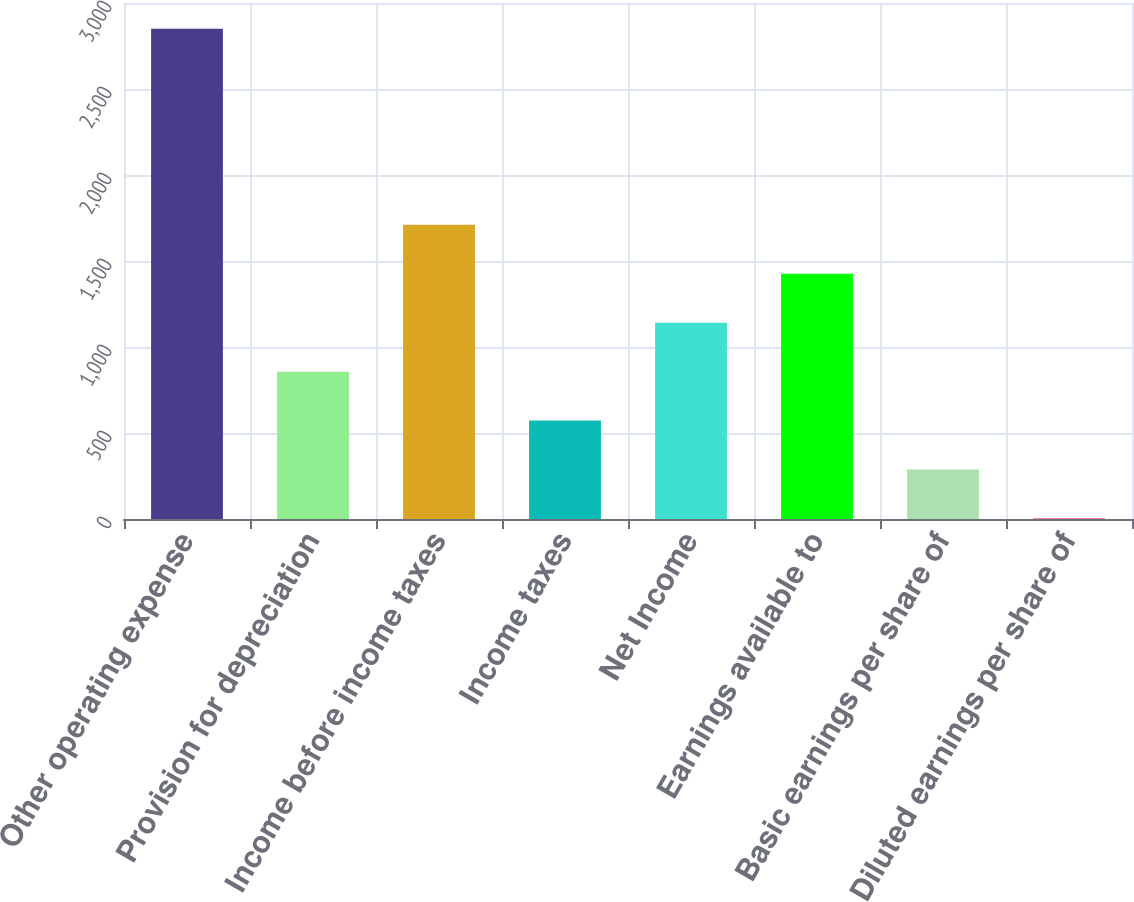Convert chart to OTSL. <chart><loc_0><loc_0><loc_500><loc_500><bar_chart><fcel>Other operating expense<fcel>Provision for depreciation<fcel>Income before income taxes<fcel>Income taxes<fcel>Net Income<fcel>Earnings available to<fcel>Basic earnings per share of<fcel>Diluted earnings per share of<nl><fcel>2850<fcel>856.79<fcel>1711.01<fcel>572.05<fcel>1141.53<fcel>1426.27<fcel>287.31<fcel>2.57<nl></chart> 